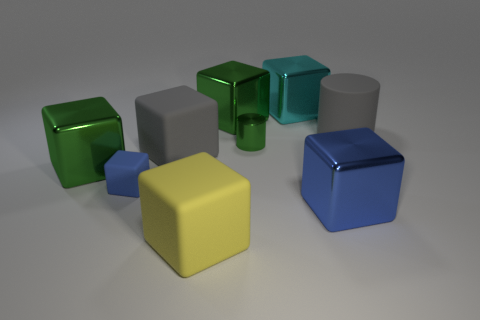There is a gray matte object left of the large blue metal object; is its shape the same as the big cyan metallic thing?
Ensure brevity in your answer.  Yes. There is a large gray thing that is the same shape as the large cyan metallic object; what is it made of?
Provide a short and direct response. Rubber. What number of cyan cubes have the same size as the yellow matte object?
Your answer should be very brief. 1. There is a big thing that is in front of the tiny blue rubber block and on the right side of the small green metal object; what color is it?
Provide a short and direct response. Blue. Are there fewer large cylinders than big red metallic blocks?
Provide a succinct answer. No. Is the color of the small rubber thing the same as the cylinder that is on the left side of the large gray matte cylinder?
Your response must be concise. No. Is the number of large green shiny blocks in front of the blue rubber thing the same as the number of large gray cubes behind the small green object?
Ensure brevity in your answer.  Yes. What number of other large yellow objects are the same shape as the yellow rubber object?
Make the answer very short. 0. Is there a small purple cylinder?
Your answer should be compact. No. Does the tiny green cylinder have the same material as the large thing that is in front of the blue metallic object?
Make the answer very short. No. 